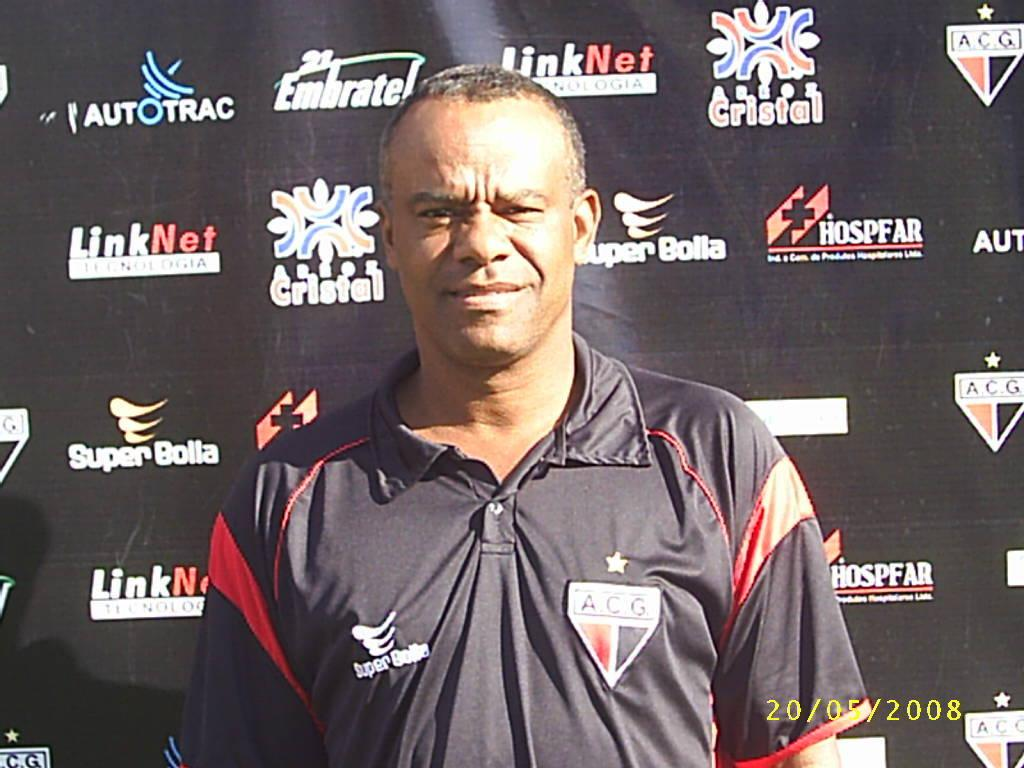Provide a one-sentence caption for the provided image. a man in front of an ad that says link. 